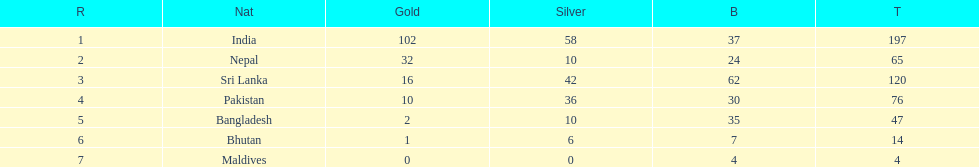What country has won no silver medals? Maldives. 